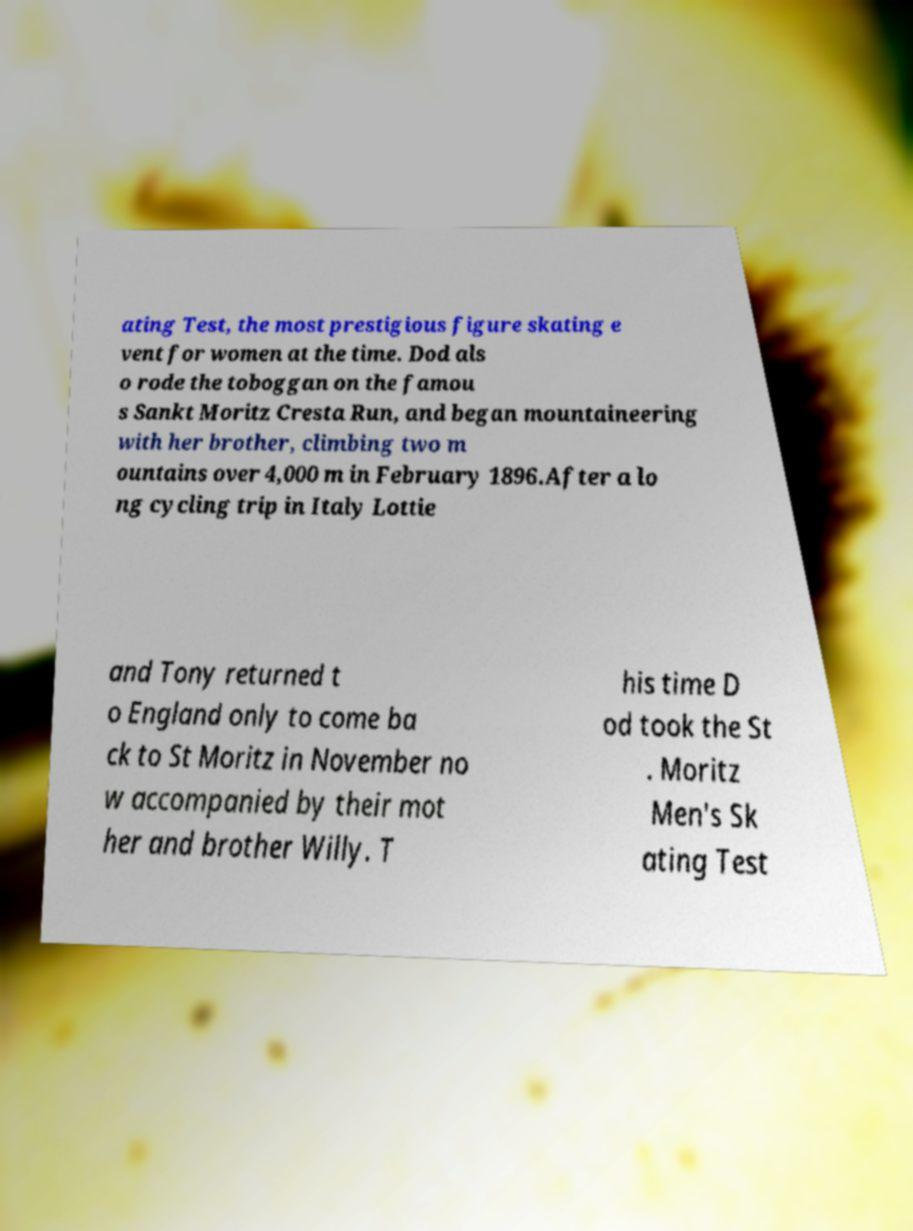Please read and relay the text visible in this image. What does it say? ating Test, the most prestigious figure skating e vent for women at the time. Dod als o rode the toboggan on the famou s Sankt Moritz Cresta Run, and began mountaineering with her brother, climbing two m ountains over 4,000 m in February 1896.After a lo ng cycling trip in Italy Lottie and Tony returned t o England only to come ba ck to St Moritz in November no w accompanied by their mot her and brother Willy. T his time D od took the St . Moritz Men's Sk ating Test 